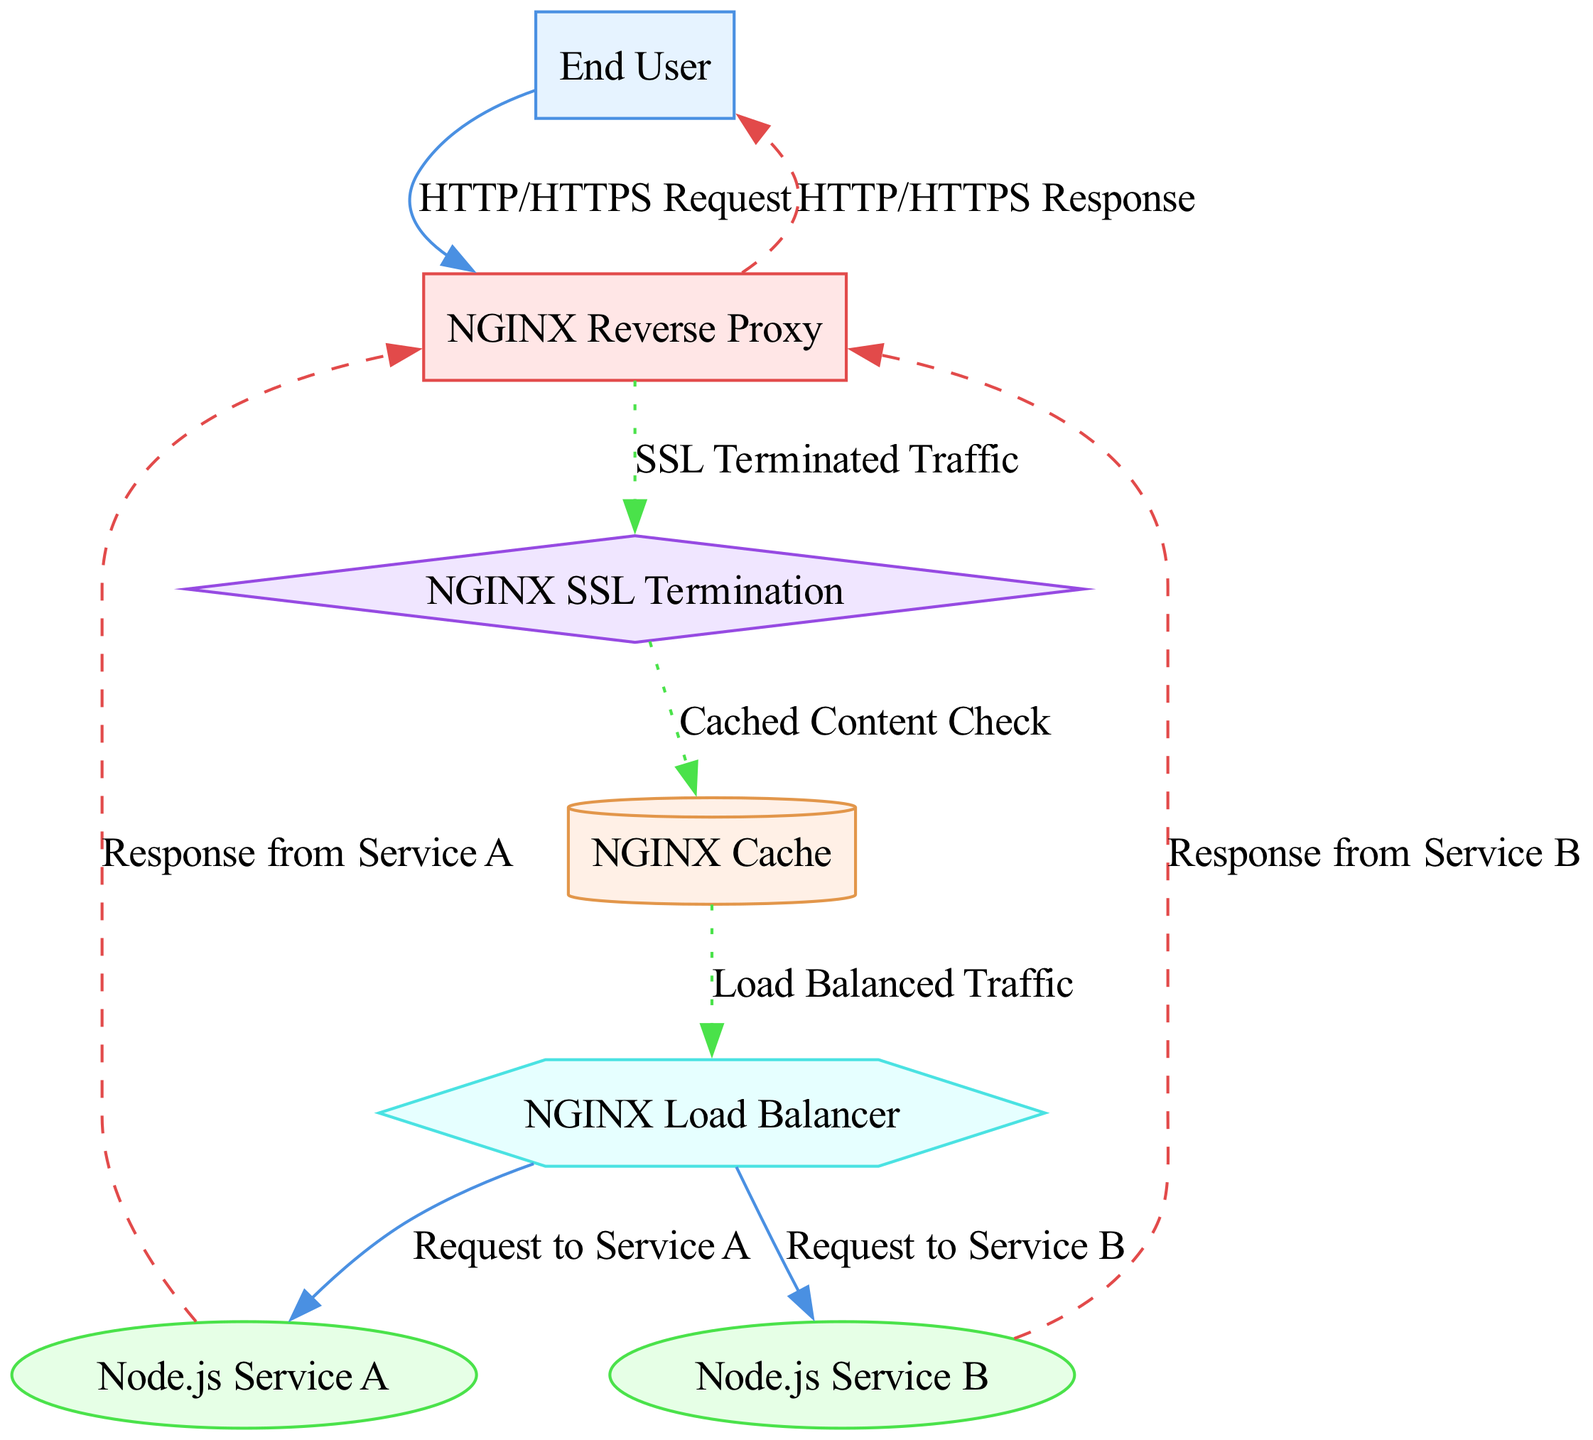What is the first node in the diagram? The first node in the diagram is labeled "End User," which represents the client or requester initiating the communication.
Answer: End User How many Node.js services are represented in the diagram? The diagram includes two Node.js services, specifically labeled "Node.js Service A" and "Node.js Service B."
Answer: 2 What type of connection is made from the NGINX Reverse Proxy to the NGINX SSL Termination? The connection from the NGINX Reverse Proxy to the NGINX SSL Termination is labeled "SSL Terminated Traffic," indicating that SSL termination is occurring at this point in the flow.
Answer: SSL Terminated Traffic Which node handles caching in the diagram? The node responsible for caching in the diagram is labeled "NGINX Cache," indicating that it stores cached content to improve request handling efficiency.
Answer: NGINX Cache How is traffic routed to Node.js Service A in the diagram? Traffic is routed to Node.js Service A through a request labeled "Request to Service A," which follows the flow from the NGINX Load Balancer directly to Service A as part of the load balancing mechanism.
Answer: Request to Service A What type of traffic exits the NGINX Reverse Proxy upon receiving a request from the End User? Upon receiving a request from the End User, the NGINX Reverse Proxy responds using "HTTP/HTTPS Response," which is the final response sent back to the End User after processing.
Answer: HTTP/HTTPS Response What is the purpose of the NGINX Load Balancer in this setup? The NGINX Load Balancer facilitates the distribution of incoming traffic, represented as "Load Balanced Traffic," allowing for efficient request handling by directing traffic to either Node.js Service A or B based on load balancing algorithms.
Answer: NGINX Load Balancer How many internal traffic connections are there to handle cached content? There is one internal traffic connection indicated in the diagram that handles the check for cached content, moving from the NGINX SSL Termination to the NGINX Cache labeled "Cached Content Check."
Answer: 1 What response does Node.js Service B send back to the NGINX Reverse Proxy? Node.js Service B sends back a response labeled "Response from Service B," which is then routed to the NGINX Reverse Proxy for final delivery to the End User.
Answer: Response from Service B 